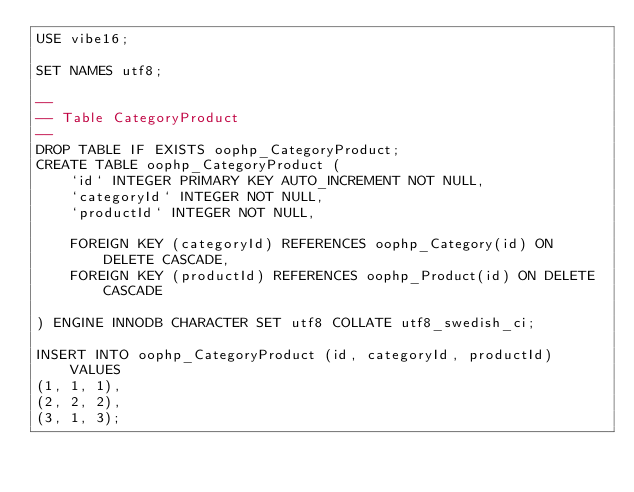Convert code to text. <code><loc_0><loc_0><loc_500><loc_500><_SQL_>USE vibe16;

SET NAMES utf8;

--
-- Table CategoryProduct
--
DROP TABLE IF EXISTS oophp_CategoryProduct;
CREATE TABLE oophp_CategoryProduct (
    `id` INTEGER PRIMARY KEY AUTO_INCREMENT NOT NULL,
    `categoryId` INTEGER NOT NULL,
    `productId` INTEGER NOT NULL,

    FOREIGN KEY (categoryId) REFERENCES oophp_Category(id) ON DELETE CASCADE,
    FOREIGN KEY (productId) REFERENCES oophp_Product(id) ON DELETE CASCADE

) ENGINE INNODB CHARACTER SET utf8 COLLATE utf8_swedish_ci;

INSERT INTO oophp_CategoryProduct (id, categoryId, productId)
    VALUES
(1, 1, 1),
(2, 2, 2),
(3, 1, 3);
</code> 